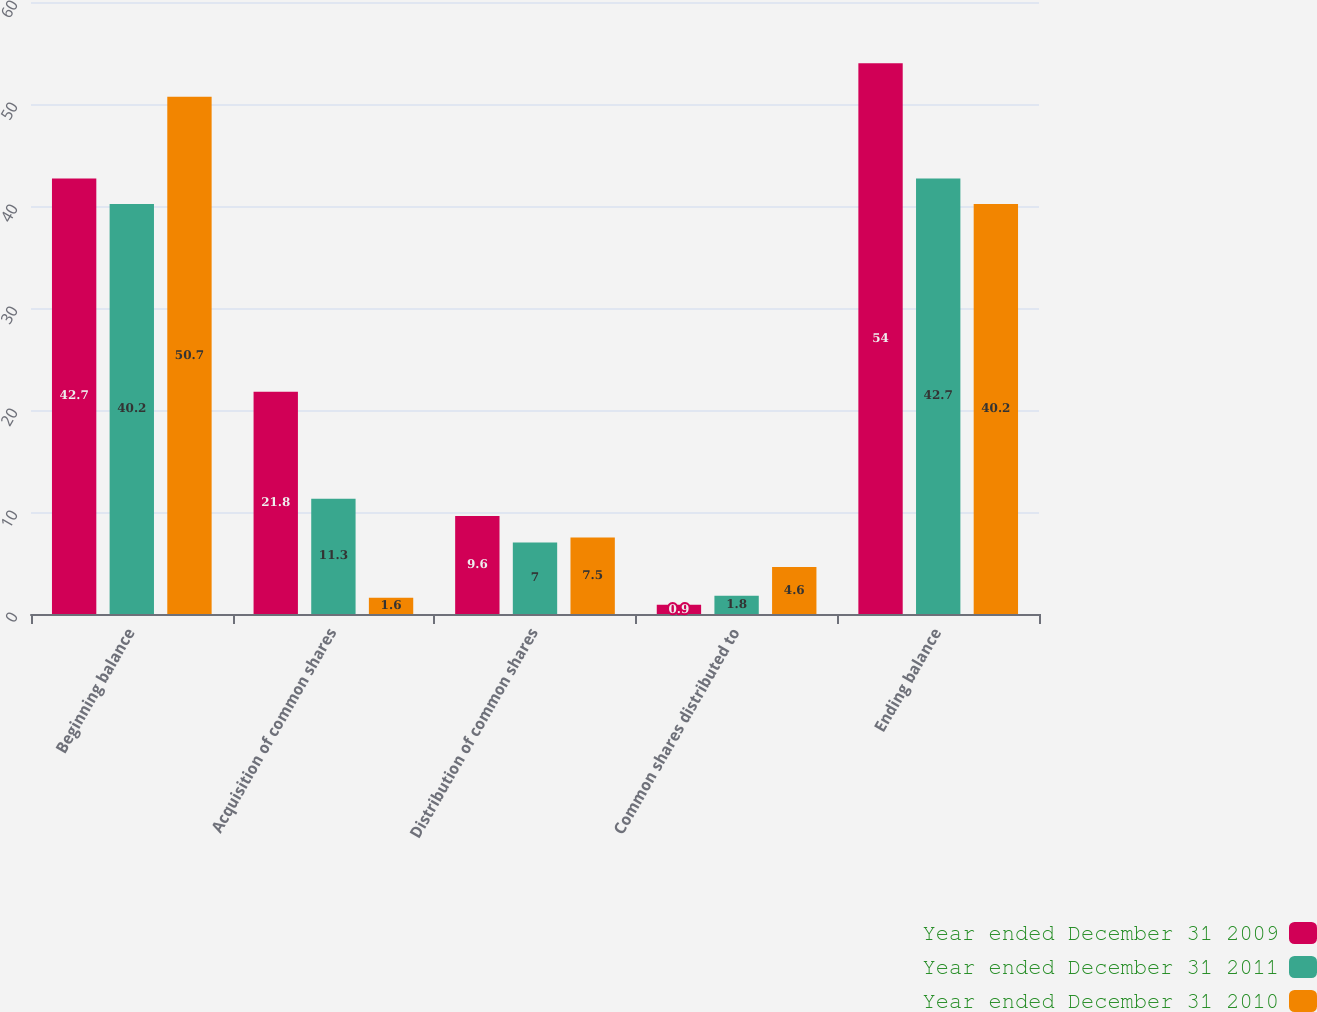Convert chart to OTSL. <chart><loc_0><loc_0><loc_500><loc_500><stacked_bar_chart><ecel><fcel>Beginning balance<fcel>Acquisition of common shares<fcel>Distribution of common shares<fcel>Common shares distributed to<fcel>Ending balance<nl><fcel>Year ended December 31 2009<fcel>42.7<fcel>21.8<fcel>9.6<fcel>0.9<fcel>54<nl><fcel>Year ended December 31 2011<fcel>40.2<fcel>11.3<fcel>7<fcel>1.8<fcel>42.7<nl><fcel>Year ended December 31 2010<fcel>50.7<fcel>1.6<fcel>7.5<fcel>4.6<fcel>40.2<nl></chart> 